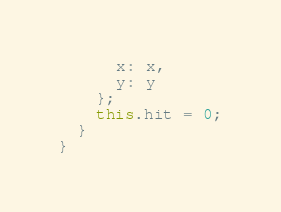Convert code to text. <code><loc_0><loc_0><loc_500><loc_500><_JavaScript_>      x: x,
      y: y
    };
    this.hit = 0;
  }
}
</code> 